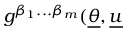Convert formula to latex. <formula><loc_0><loc_0><loc_500><loc_500>g ^ { \beta _ { 1 } \dots \beta _ { m } } ( \underline { \theta } , \underline { u }</formula> 